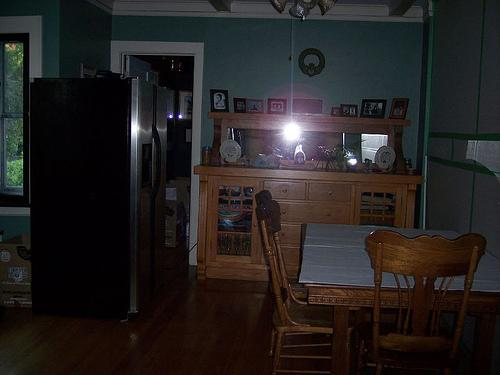What is the large silver object to the left used to store? food 